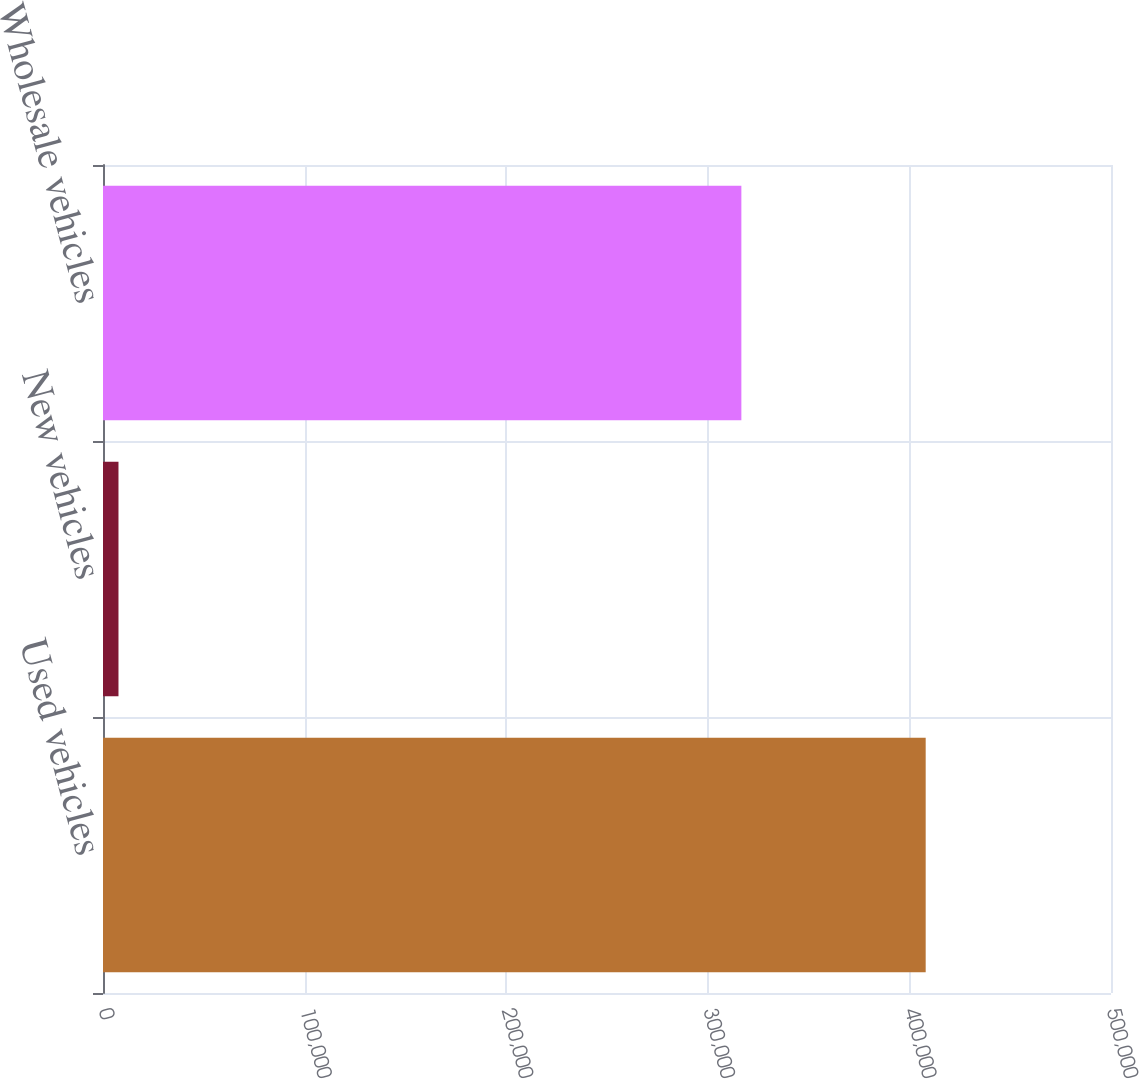Convert chart to OTSL. <chart><loc_0><loc_0><loc_500><loc_500><bar_chart><fcel>Used vehicles<fcel>New vehicles<fcel>Wholesale vehicles<nl><fcel>408080<fcel>7679<fcel>316649<nl></chart> 